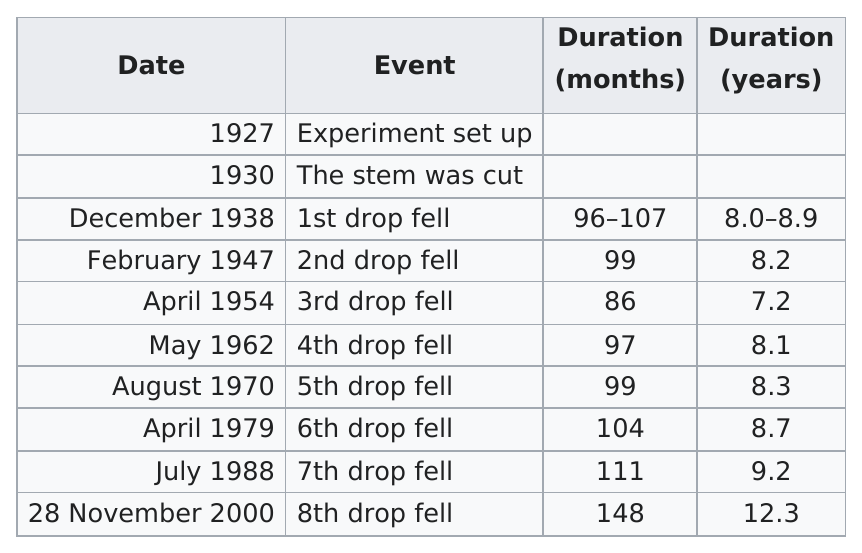Highlight a few significant elements in this photo. The third drop in the experiment fell in April 1954. The first drop in the experiment fell in December 1938. The second drop was dropped in the experiment on February 1947. 